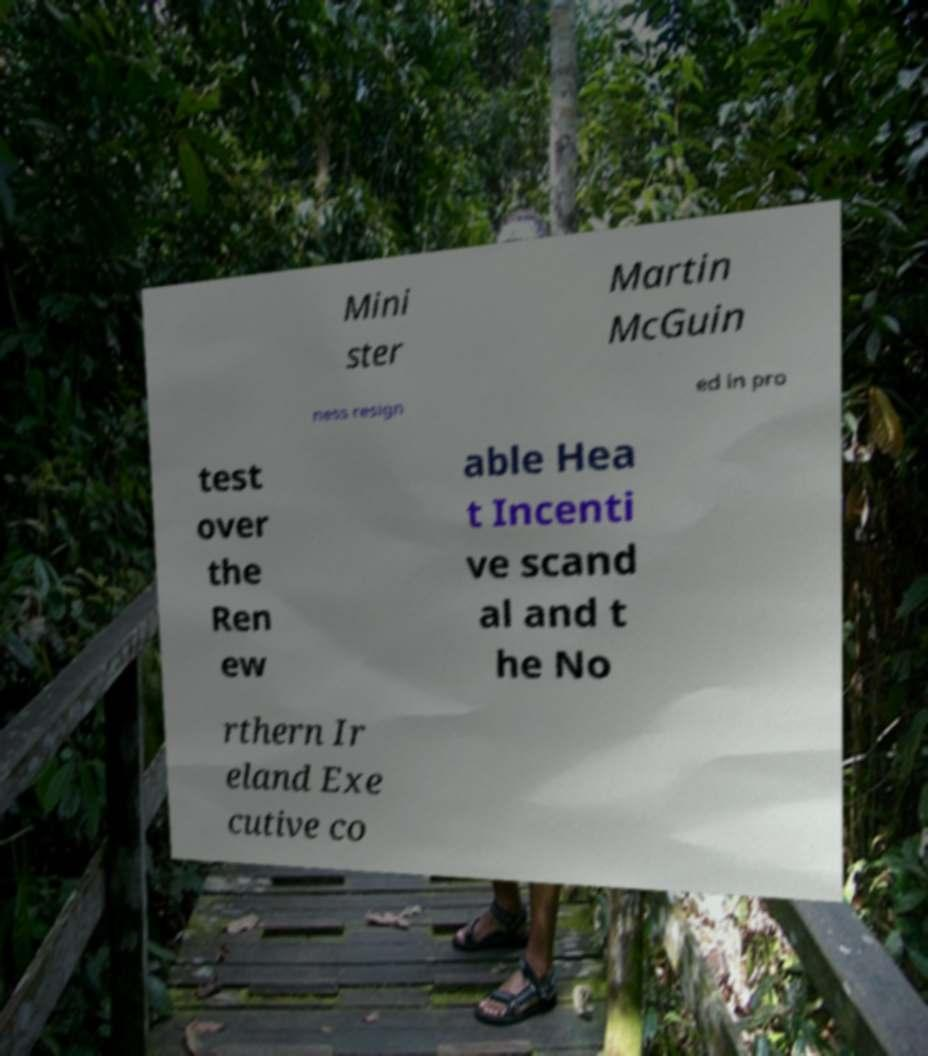There's text embedded in this image that I need extracted. Can you transcribe it verbatim? Mini ster Martin McGuin ness resign ed in pro test over the Ren ew able Hea t Incenti ve scand al and t he No rthern Ir eland Exe cutive co 